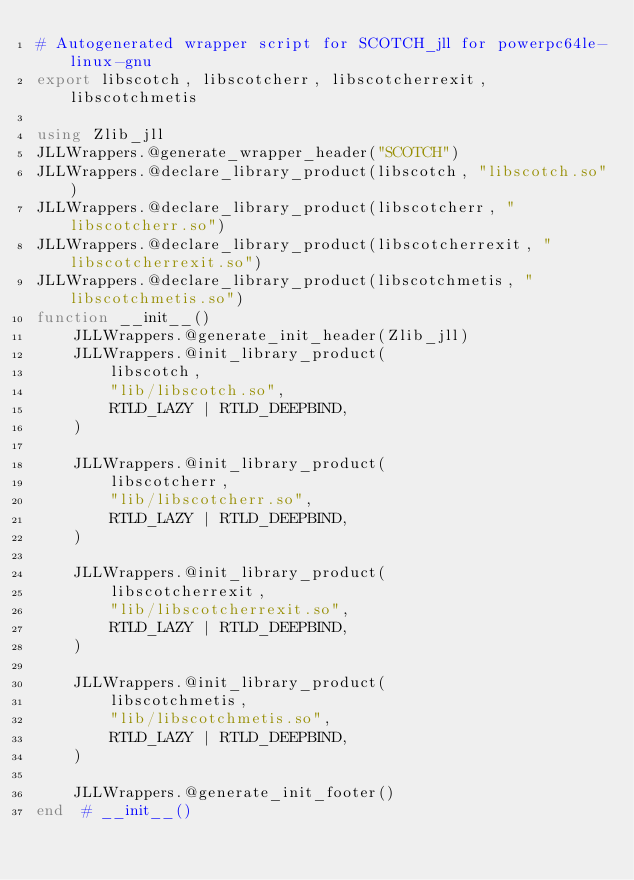<code> <loc_0><loc_0><loc_500><loc_500><_Julia_># Autogenerated wrapper script for SCOTCH_jll for powerpc64le-linux-gnu
export libscotch, libscotcherr, libscotcherrexit, libscotchmetis

using Zlib_jll
JLLWrappers.@generate_wrapper_header("SCOTCH")
JLLWrappers.@declare_library_product(libscotch, "libscotch.so")
JLLWrappers.@declare_library_product(libscotcherr, "libscotcherr.so")
JLLWrappers.@declare_library_product(libscotcherrexit, "libscotcherrexit.so")
JLLWrappers.@declare_library_product(libscotchmetis, "libscotchmetis.so")
function __init__()
    JLLWrappers.@generate_init_header(Zlib_jll)
    JLLWrappers.@init_library_product(
        libscotch,
        "lib/libscotch.so",
        RTLD_LAZY | RTLD_DEEPBIND,
    )

    JLLWrappers.@init_library_product(
        libscotcherr,
        "lib/libscotcherr.so",
        RTLD_LAZY | RTLD_DEEPBIND,
    )

    JLLWrappers.@init_library_product(
        libscotcherrexit,
        "lib/libscotcherrexit.so",
        RTLD_LAZY | RTLD_DEEPBIND,
    )

    JLLWrappers.@init_library_product(
        libscotchmetis,
        "lib/libscotchmetis.so",
        RTLD_LAZY | RTLD_DEEPBIND,
    )

    JLLWrappers.@generate_init_footer()
end  # __init__()
</code> 